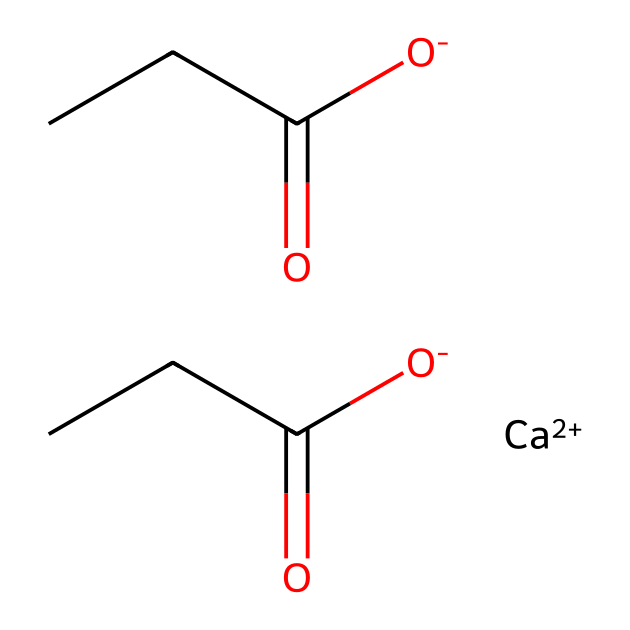What is the chemical formula for calcium propionate? The SMILES representation shows two propionate groups along with a calcium ion, which collectively form calcium propionate. Thus, the chemical formula is C6H10CaO4.
Answer: C6H10CaO4 How many carbon atoms are in calcium propionate? By inspecting the structure, there are six carbon atoms across the two propionate moieties. Each propionate (C3H5O2) contributes three carbon atoms.
Answer: 6 What type of bond connects the calcium ion to the propionate groups in calcium propionate? In the SMILES string, the calcium ion is indicated to interact ionically with the negatively charged propionate groups, forming ionic bonds.
Answer: Ionic Is calcium propionate a salt or an organic compound? Calcium propionate is formed from the reaction of a calcium salt and propionic acid, classifying it as a salt while also retaining characteristics of organic compounds due to its propionate moieties.
Answer: Salt What functional groups are present in calcium propionate? Observing the structure indicates the presence of carboxylate groups (-COO-) in the propionate portions, making them the primary functional groups present.
Answer: Carboxylate Why is calcium propionate used as a preservative? The chemical structure allows it to inhibit mold and bacteria growth in baked goods, making it effective for preservation without altering food flavor significantly.
Answer: Inhibit mold 